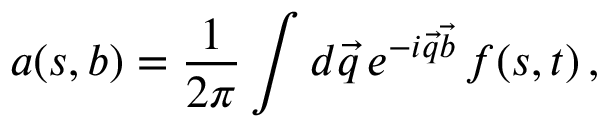Convert formula to latex. <formula><loc_0><loc_0><loc_500><loc_500>a ( s , b ) = { \frac { 1 } { 2 \pi } } \int d \vec { q } \, e ^ { - i \vec { q } \vec { b } } \, f ( s , t ) \, ,</formula> 